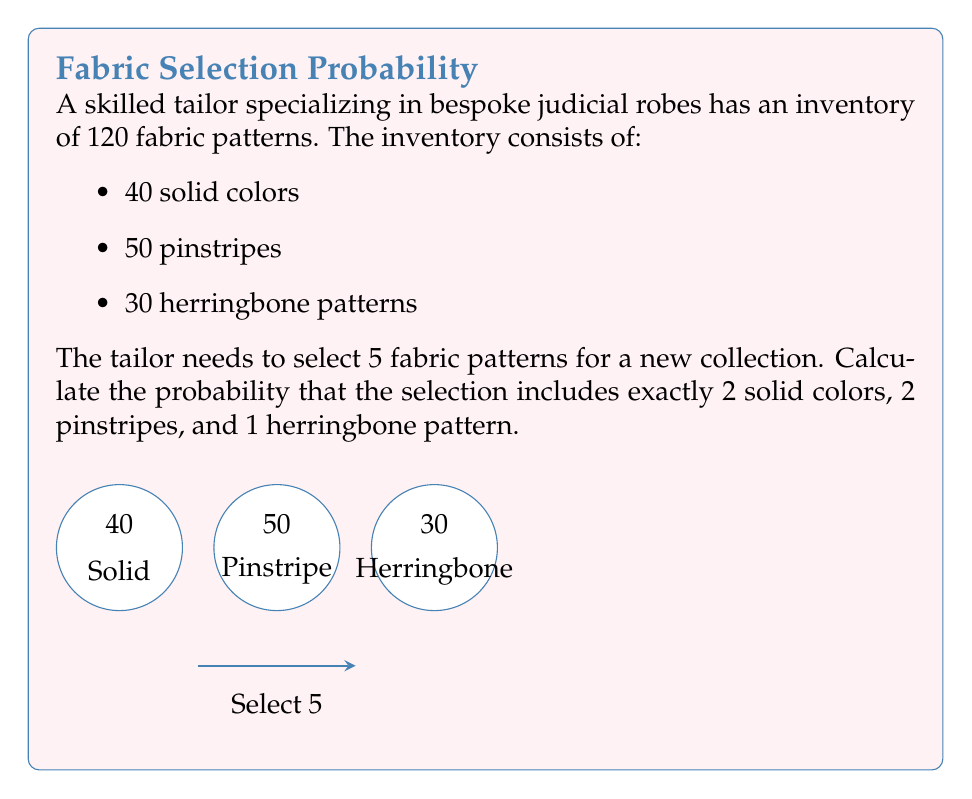Give your solution to this math problem. Let's approach this step-by-step:

1) First, we need to calculate the number of ways to select the specific combination:
   - 2 solid colors out of 40
   - 2 pinstripes out of 50
   - 1 herringbone out of 30

2) For each of these, we use the combination formula:
   $${n \choose k} = \frac{n!}{k!(n-k)!}$$

3) Number of ways to select 2 solid colors out of 40:
   $${40 \choose 2} = \frac{40!}{2!(40-2)!} = \frac{40!}{2!38!} = 780$$

4) Number of ways to select 2 pinstripes out of 50:
   $${50 \choose 2} = \frac{50!}{2!(50-2)!} = \frac{50!}{2!48!} = 1225$$

5) Number of ways to select 1 herringbone out of 30:
   $${30 \choose 1} = \frac{30!}{1!(30-1)!} = \frac{30!}{1!29!} = 30$$

6) The total number of favorable outcomes is the product of these:
   $$780 \times 1225 \times 30 = 28,665,000$$

7) Now, we need to calculate the total number of ways to select 5 fabrics out of 120:
   $${120 \choose 5} = \frac{120!}{5!(120-5)!} = \frac{120!}{5!115!} = 190,578,024$$

8) The probability is the number of favorable outcomes divided by the total number of possible outcomes:

   $$P(\text{2 solid, 2 pinstripe, 1 herringbone}) = \frac{28,665,000}{190,578,024}$$

9) Simplifying this fraction:
   $$\frac{28,665,000}{190,578,024} = \frac{143,325}{952,890} \approx 0.1504$$
Answer: $\frac{143,325}{952,890}$ or approximately 0.1504 